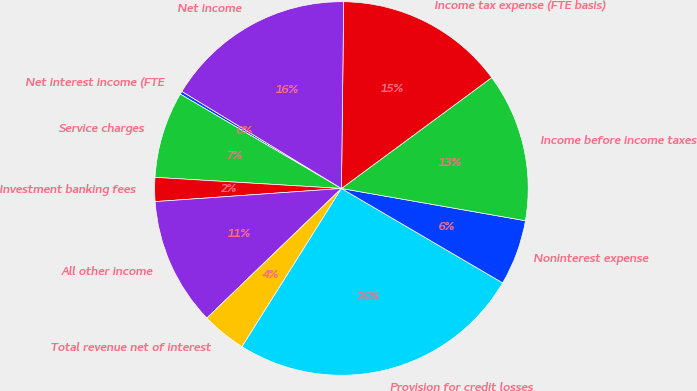Convert chart. <chart><loc_0><loc_0><loc_500><loc_500><pie_chart><fcel>Net interest income (FTE<fcel>Service charges<fcel>Investment banking fees<fcel>All other income<fcel>Total revenue net of interest<fcel>Provision for credit losses<fcel>Noninterest expense<fcel>Income before income taxes<fcel>Income tax expense (FTE basis)<fcel>Net income<nl><fcel>0.27%<fcel>7.48%<fcel>2.07%<fcel>11.08%<fcel>3.87%<fcel>25.5%<fcel>5.67%<fcel>12.88%<fcel>14.69%<fcel>16.49%<nl></chart> 